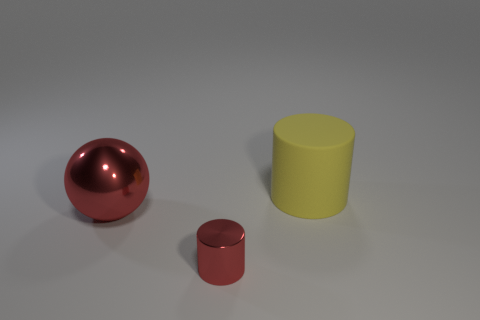Add 1 small cylinders. How many objects exist? 4 Subtract all yellow cylinders. How many cylinders are left? 1 Subtract 1 spheres. How many spheres are left? 0 Add 3 rubber cylinders. How many rubber cylinders are left? 4 Add 2 small rubber cubes. How many small rubber cubes exist? 2 Subtract 0 cyan spheres. How many objects are left? 3 Subtract all balls. How many objects are left? 2 Subtract all red cylinders. Subtract all gray balls. How many cylinders are left? 1 Subtract all gray blocks. How many red cylinders are left? 1 Subtract all yellow rubber things. Subtract all cylinders. How many objects are left? 0 